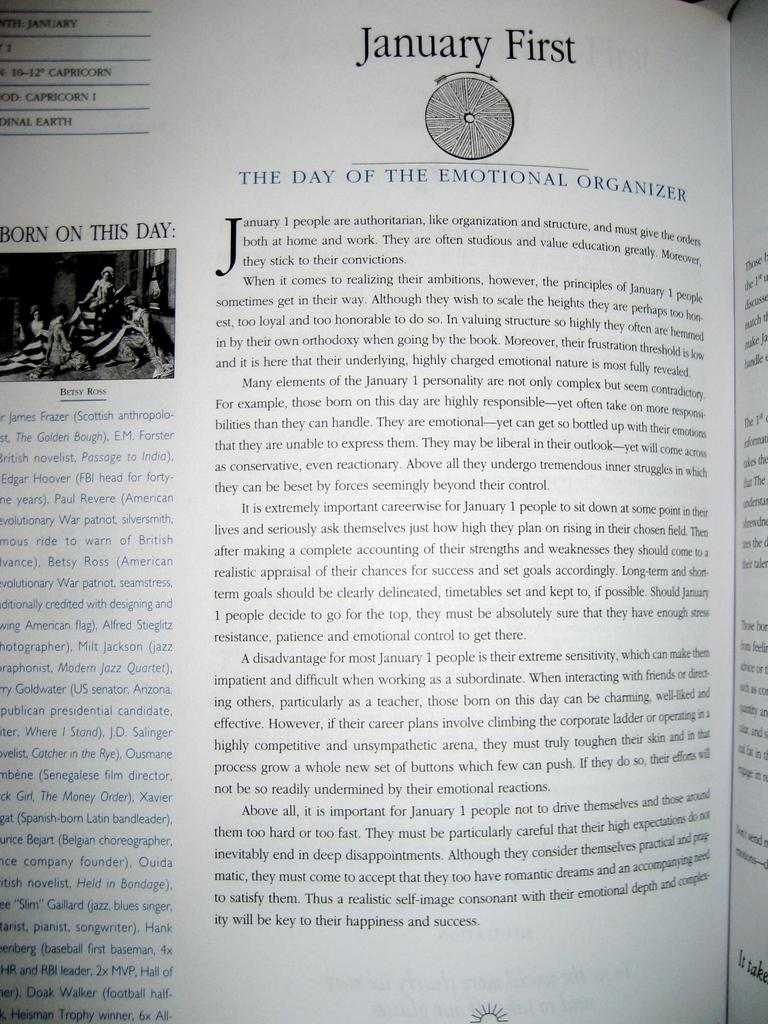Provide a one-sentence caption for the provided image. Opened page from a book named "January First". 